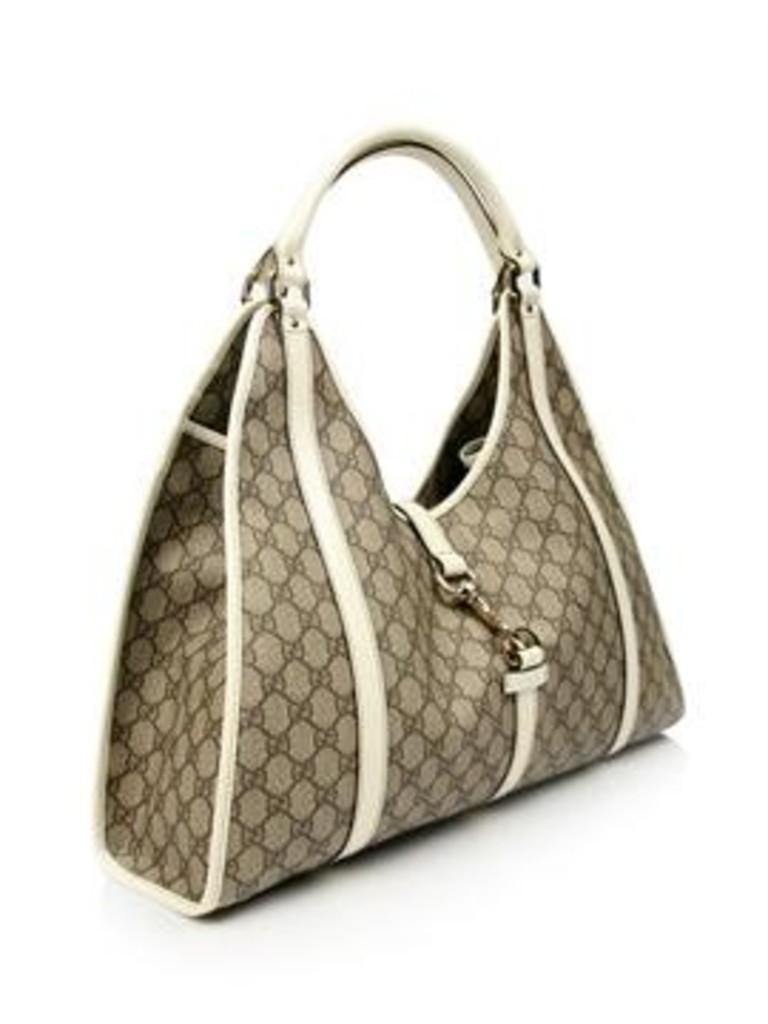What object can be seen in the image? There is a bag in the image. What part of the bag is filled with honey in the image? There is no honey mentioned or visible in the image; it only features a bag. 